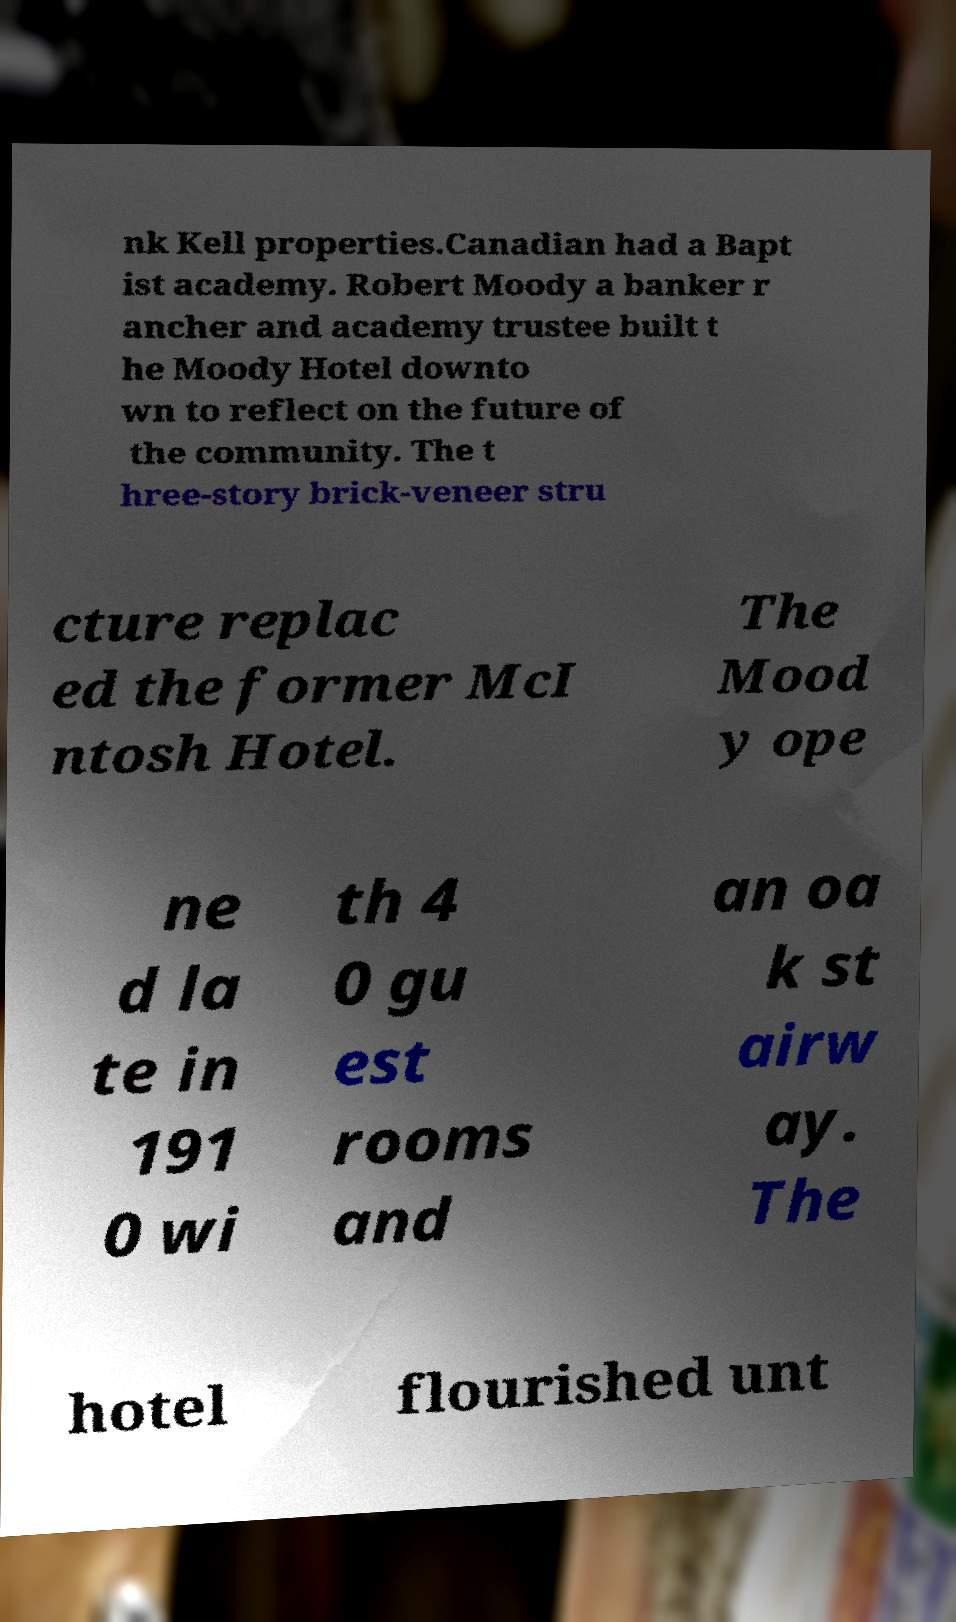Can you read and provide the text displayed in the image?This photo seems to have some interesting text. Can you extract and type it out for me? nk Kell properties.Canadian had a Bapt ist academy. Robert Moody a banker r ancher and academy trustee built t he Moody Hotel downto wn to reflect on the future of the community. The t hree-story brick-veneer stru cture replac ed the former McI ntosh Hotel. The Mood y ope ne d la te in 191 0 wi th 4 0 gu est rooms and an oa k st airw ay. The hotel flourished unt 